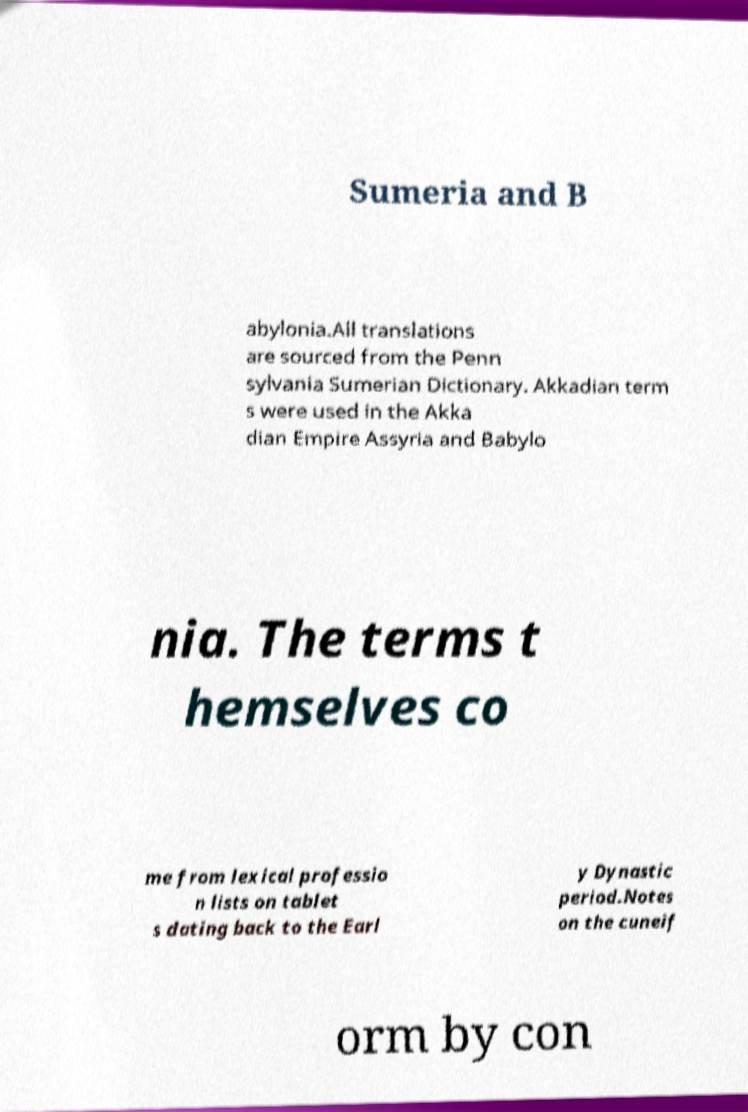Please read and relay the text visible in this image. What does it say? Sumeria and B abylonia.All translations are sourced from the Penn sylvania Sumerian Dictionary. Akkadian term s were used in the Akka dian Empire Assyria and Babylo nia. The terms t hemselves co me from lexical professio n lists on tablet s dating back to the Earl y Dynastic period.Notes on the cuneif orm by con 